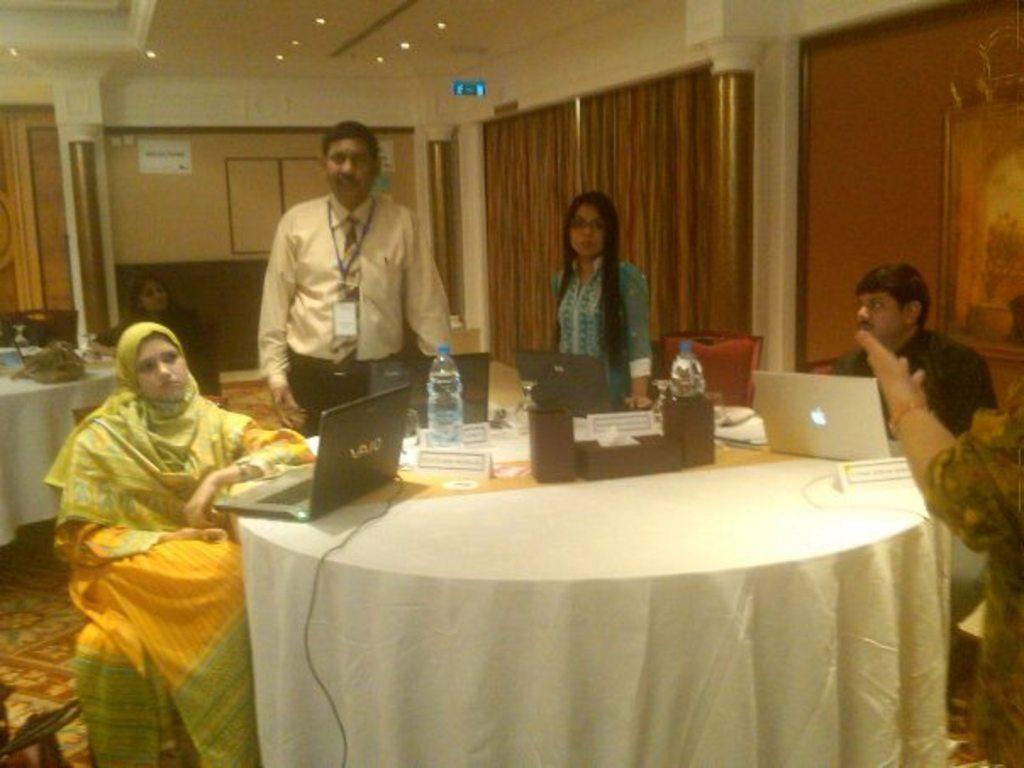In one or two sentences, can you explain what this image depicts? In this picture we can see six people where one man and woman are standing and other are sitting on chair and in front of them on table we have laptop, wires, bottles, name boards and in background we can see wall, curtains. 